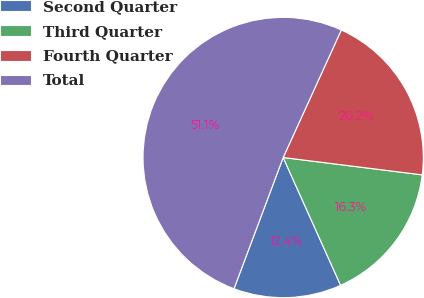Convert chart to OTSL. <chart><loc_0><loc_0><loc_500><loc_500><pie_chart><fcel>Second Quarter<fcel>Third Quarter<fcel>Fourth Quarter<fcel>Total<nl><fcel>12.43%<fcel>16.3%<fcel>20.17%<fcel>51.1%<nl></chart> 